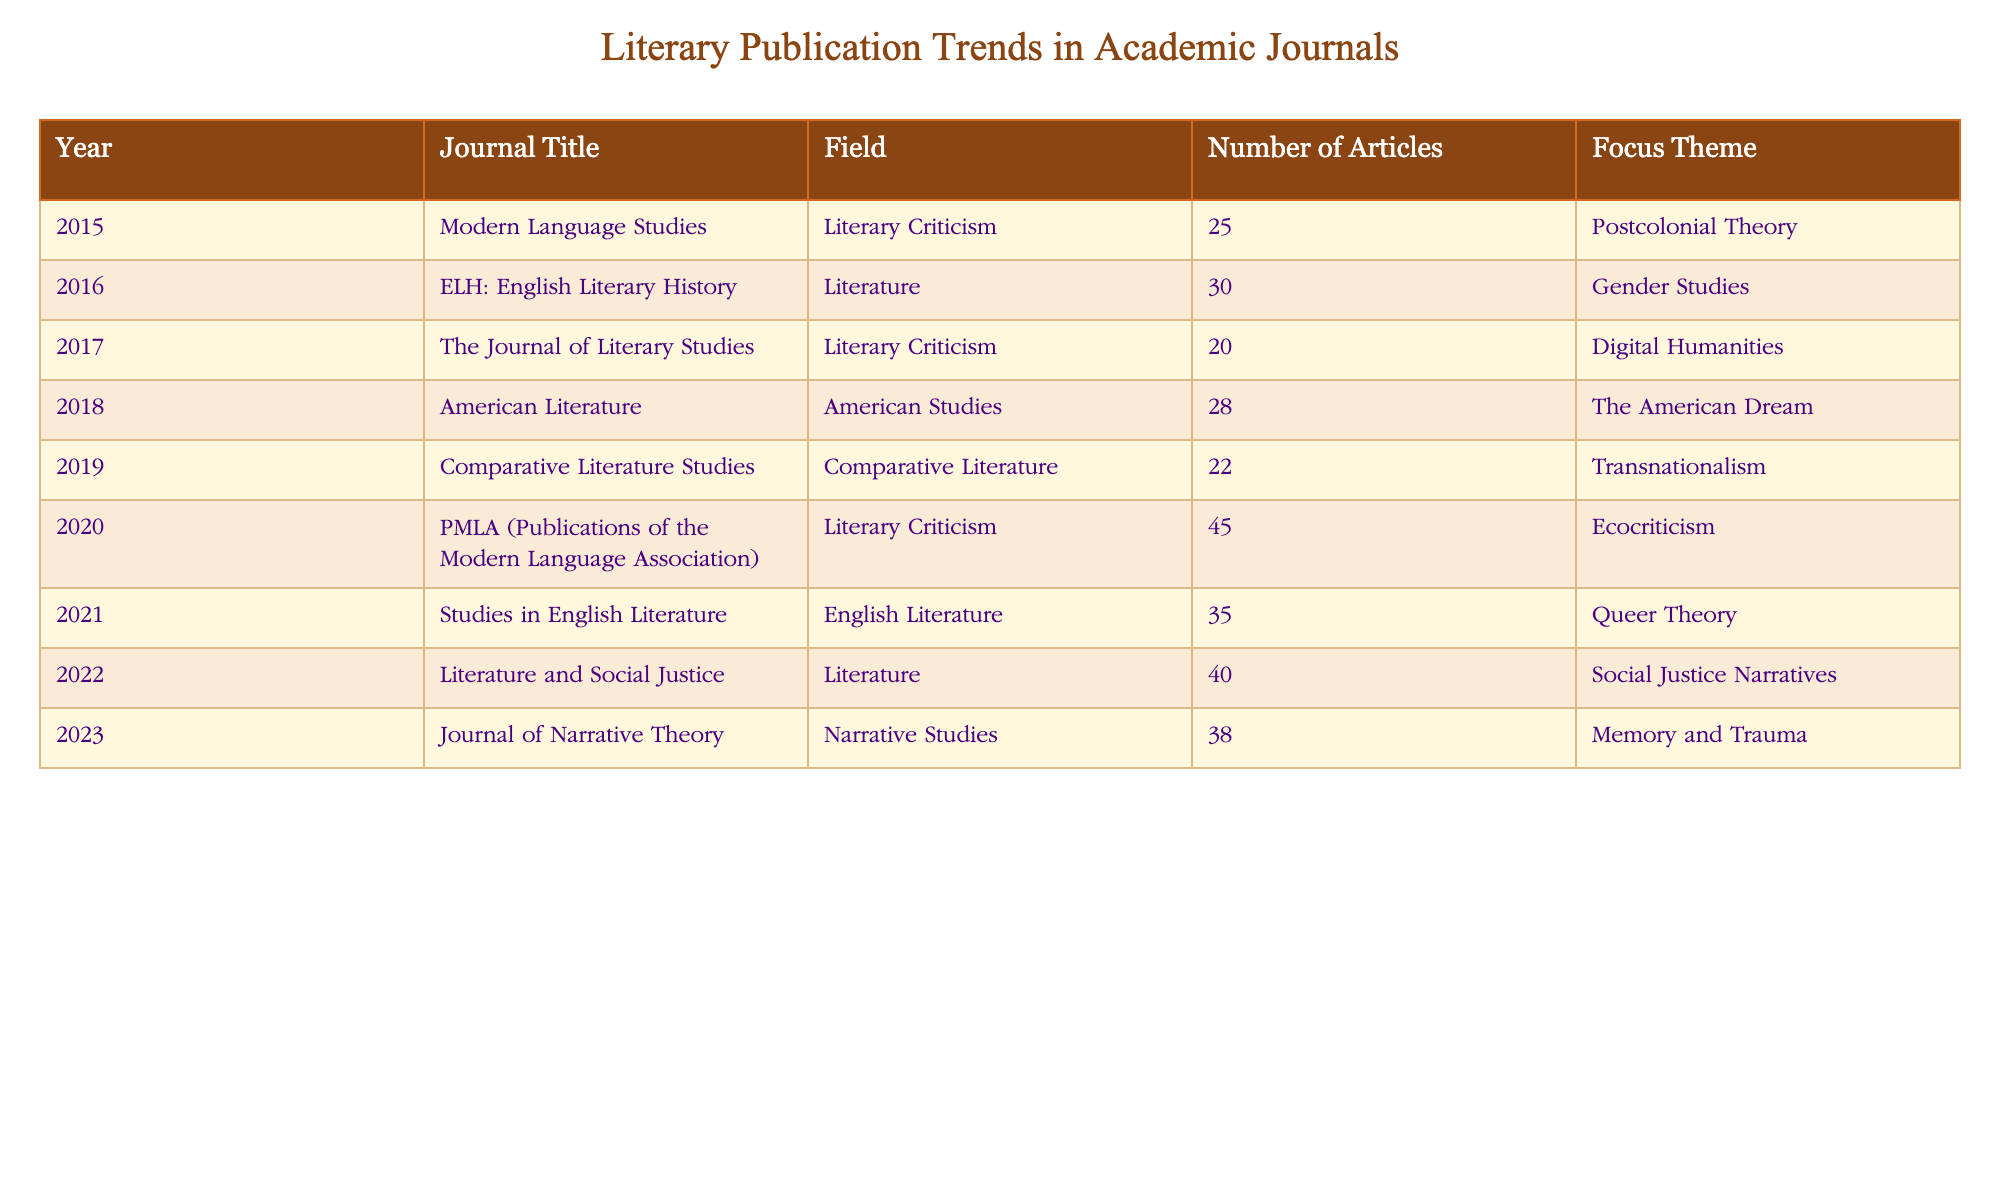What was the highest number of articles published in a single year? By examining the "Number of Articles" column, we find that the year 2020 had the highest count at 45 articles.
Answer: 45 In which field was the focus theme of "Memory and Trauma" published? "Memory and Trauma" was published in the "Journal of Narrative Theory," which is categorized under "Narrative Studies."
Answer: Narrative Studies What is the average number of articles published in the years 2015 to 2018? The number of articles for those years is 25, 30, 20, and 28 respectively. To find the average, sum these values: 25 + 30 + 20 + 28 = 103, then divide by 4 (the number of years) gives us 103 / 4 = 25.75.
Answer: 25.75 Did "ELH: English Literary History" focus on Gender Studies? Yes, "ELH: English Literary History" listed "Gender Studies" as its focus theme.
Answer: Yes Which years had a focus theme related to justice or societal themes? The years 2020 with "Ecocriticism" and 2022 with "Social Justice Narratives" both address societal themes, but 2022 is explicitly focused on justice.
Answer: 2022 What was the total number of articles published in 2021 and 2022 combined? From the table, the number of articles for 2021 is 35 and for 2022 is 40. Adding these gives: 35 + 40 = 75.
Answer: 75 Was there a year in which the theme included "Transnationalism"? Yes, the year 2019 featured "Transnationalism" as its focus theme in "Comparative Literature Studies."
Answer: Yes What focus themes were present for articles published from 2015 to 2019? The themes during these years were "Postcolonial Theory," "Gender Studies," "Digital Humanities," "The American Dream," and "Transnationalism." Listing them gives an overview of prevalent cultural discourse.
Answer: Postcolonial Theory, Gender Studies, Digital Humanities, The American Dream, Transnationalism 